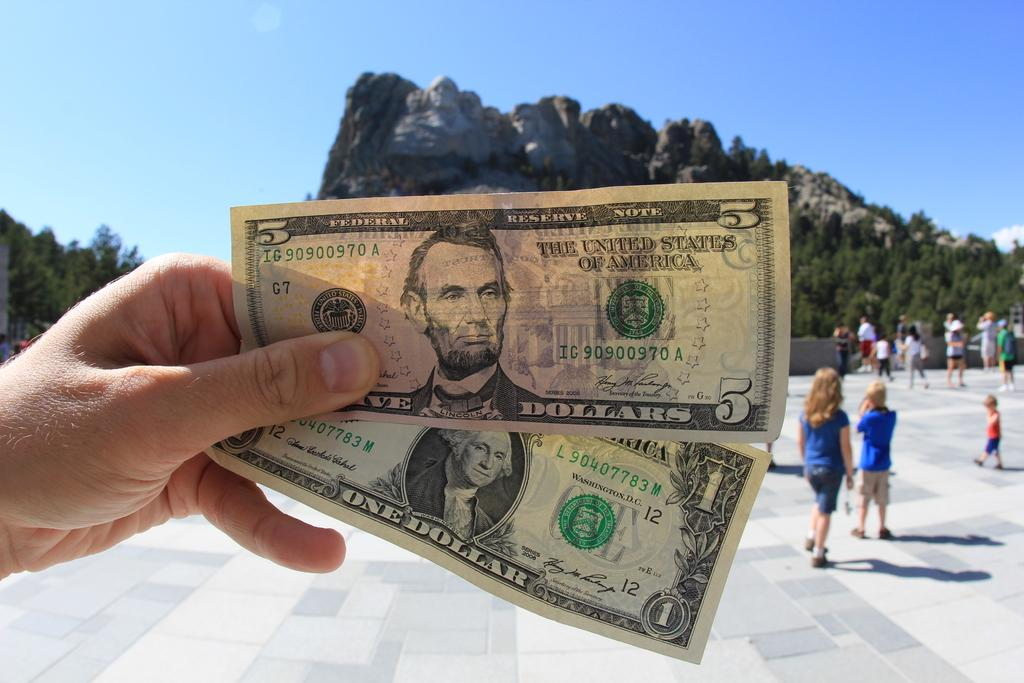How many people are in the image? There are people in the image, but the exact number is not specified. What is one person holding in the image? One person is holding a dollar bill in the image. What can be seen in the background of the image? In the background of the image, there are mountains, trees, and the sky. What type of vegetable is being cut with a knife in the image? There is no vegetable or knife present in the image. 